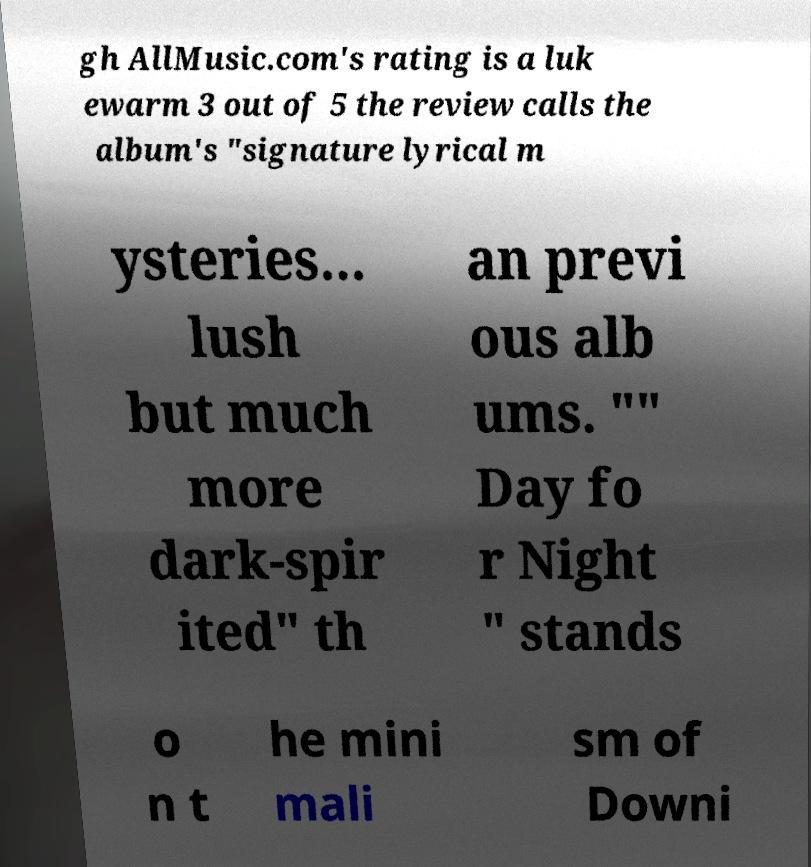I need the written content from this picture converted into text. Can you do that? gh AllMusic.com's rating is a luk ewarm 3 out of 5 the review calls the album's "signature lyrical m ysteries... lush but much more dark-spir ited" th an previ ous alb ums. "" Day fo r Night " stands o n t he mini mali sm of Downi 